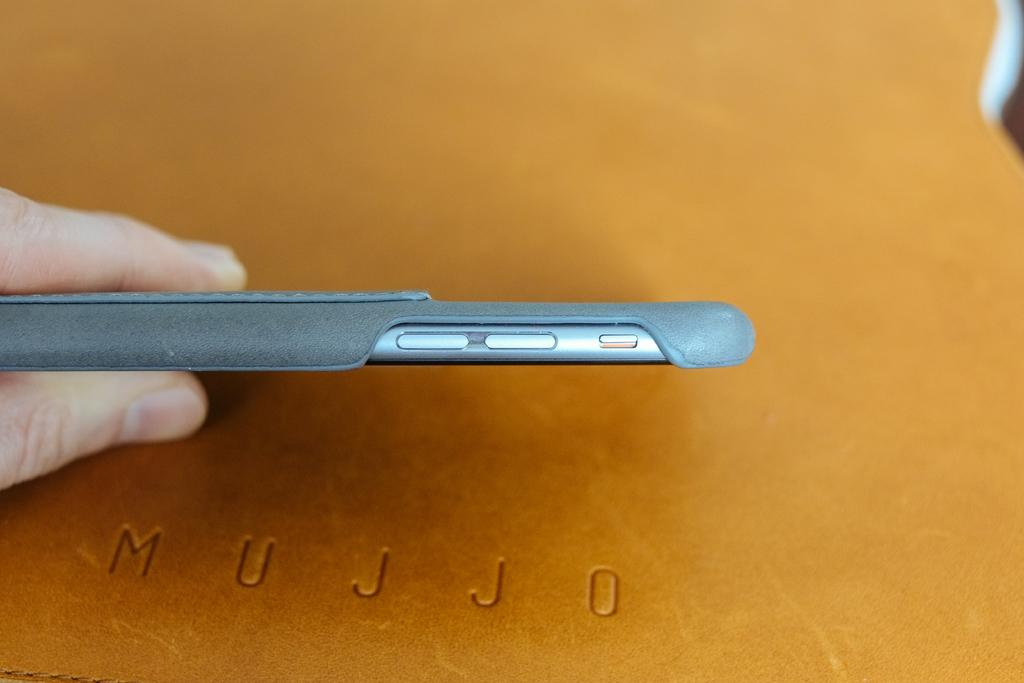<image>
Share a concise interpretation of the image provided. Phone on top of a Mujjo folder that is brown 